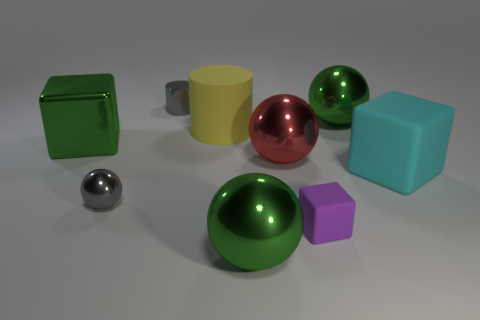Is the shape of the big matte thing left of the small rubber block the same as the small gray thing that is behind the large green metallic block?
Make the answer very short. Yes. What shape is the small object that is behind the big red sphere on the right side of the ball that is on the left side of the yellow object?
Provide a succinct answer. Cylinder. What number of other objects are the same shape as the tiny matte object?
Give a very brief answer. 2. The cylinder that is the same size as the red sphere is what color?
Ensure brevity in your answer.  Yellow. What number of blocks are either tiny gray things or big cyan rubber objects?
Offer a terse response. 1. What number of green metallic objects are there?
Provide a succinct answer. 3. Does the big cyan thing have the same shape as the green shiny thing that is on the left side of the yellow thing?
Your answer should be compact. Yes. What size is the shiny sphere that is the same color as the shiny cylinder?
Provide a succinct answer. Small. What number of objects are either red cylinders or shiny things?
Your response must be concise. 6. What shape is the small purple object that is on the right side of the gray thing that is in front of the large cyan block?
Offer a very short reply. Cube. 